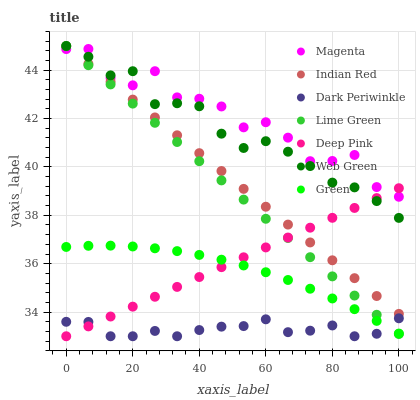Does Dark Periwinkle have the minimum area under the curve?
Answer yes or no. Yes. Does Magenta have the maximum area under the curve?
Answer yes or no. Yes. Does Web Green have the minimum area under the curve?
Answer yes or no. No. Does Web Green have the maximum area under the curve?
Answer yes or no. No. Is Deep Pink the smoothest?
Answer yes or no. Yes. Is Magenta the roughest?
Answer yes or no. Yes. Is Web Green the smoothest?
Answer yes or no. No. Is Web Green the roughest?
Answer yes or no. No. Does Deep Pink have the lowest value?
Answer yes or no. Yes. Does Web Green have the lowest value?
Answer yes or no. No. Does Lime Green have the highest value?
Answer yes or no. Yes. Does Green have the highest value?
Answer yes or no. No. Is Green less than Magenta?
Answer yes or no. Yes. Is Magenta greater than Dark Periwinkle?
Answer yes or no. Yes. Does Lime Green intersect Magenta?
Answer yes or no. Yes. Is Lime Green less than Magenta?
Answer yes or no. No. Is Lime Green greater than Magenta?
Answer yes or no. No. Does Green intersect Magenta?
Answer yes or no. No. 